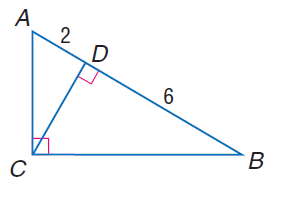Question: Find the measure of the altitude drawn to the hypotenuse.
Choices:
A. 2 \sqrt { 3 }
B. 2 \sqrt { 6 }
C. 2 \sqrt { 6 }
D. 4 \sqrt { 3 }
Answer with the letter. Answer: A 